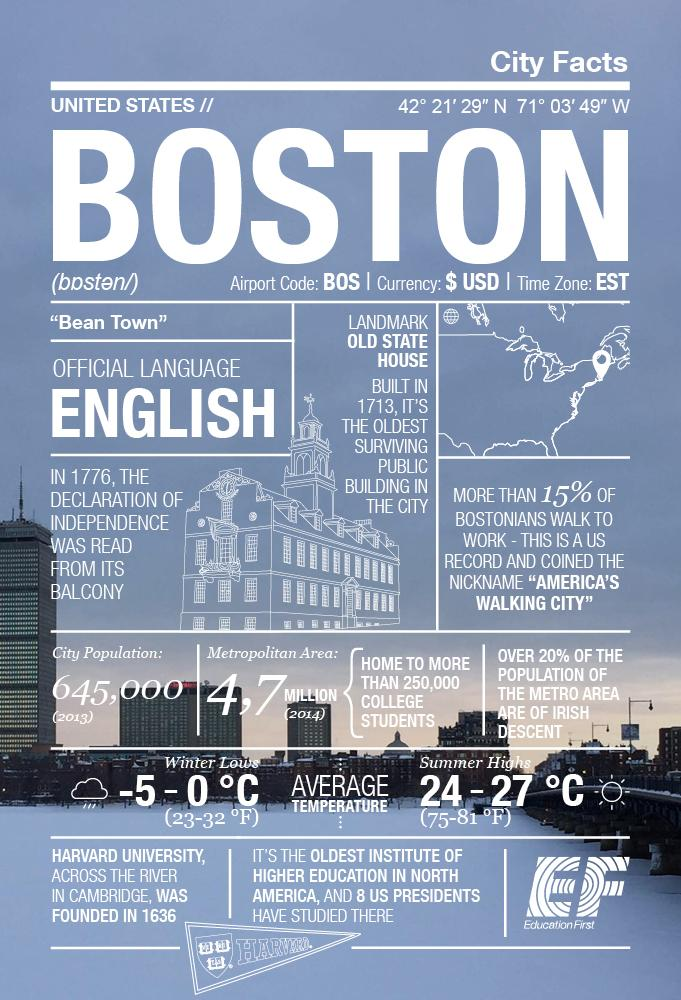Point out several critical features in this image. The range of temperature in summer in Boston is between 75 and 81 degrees Fahrenheit. 